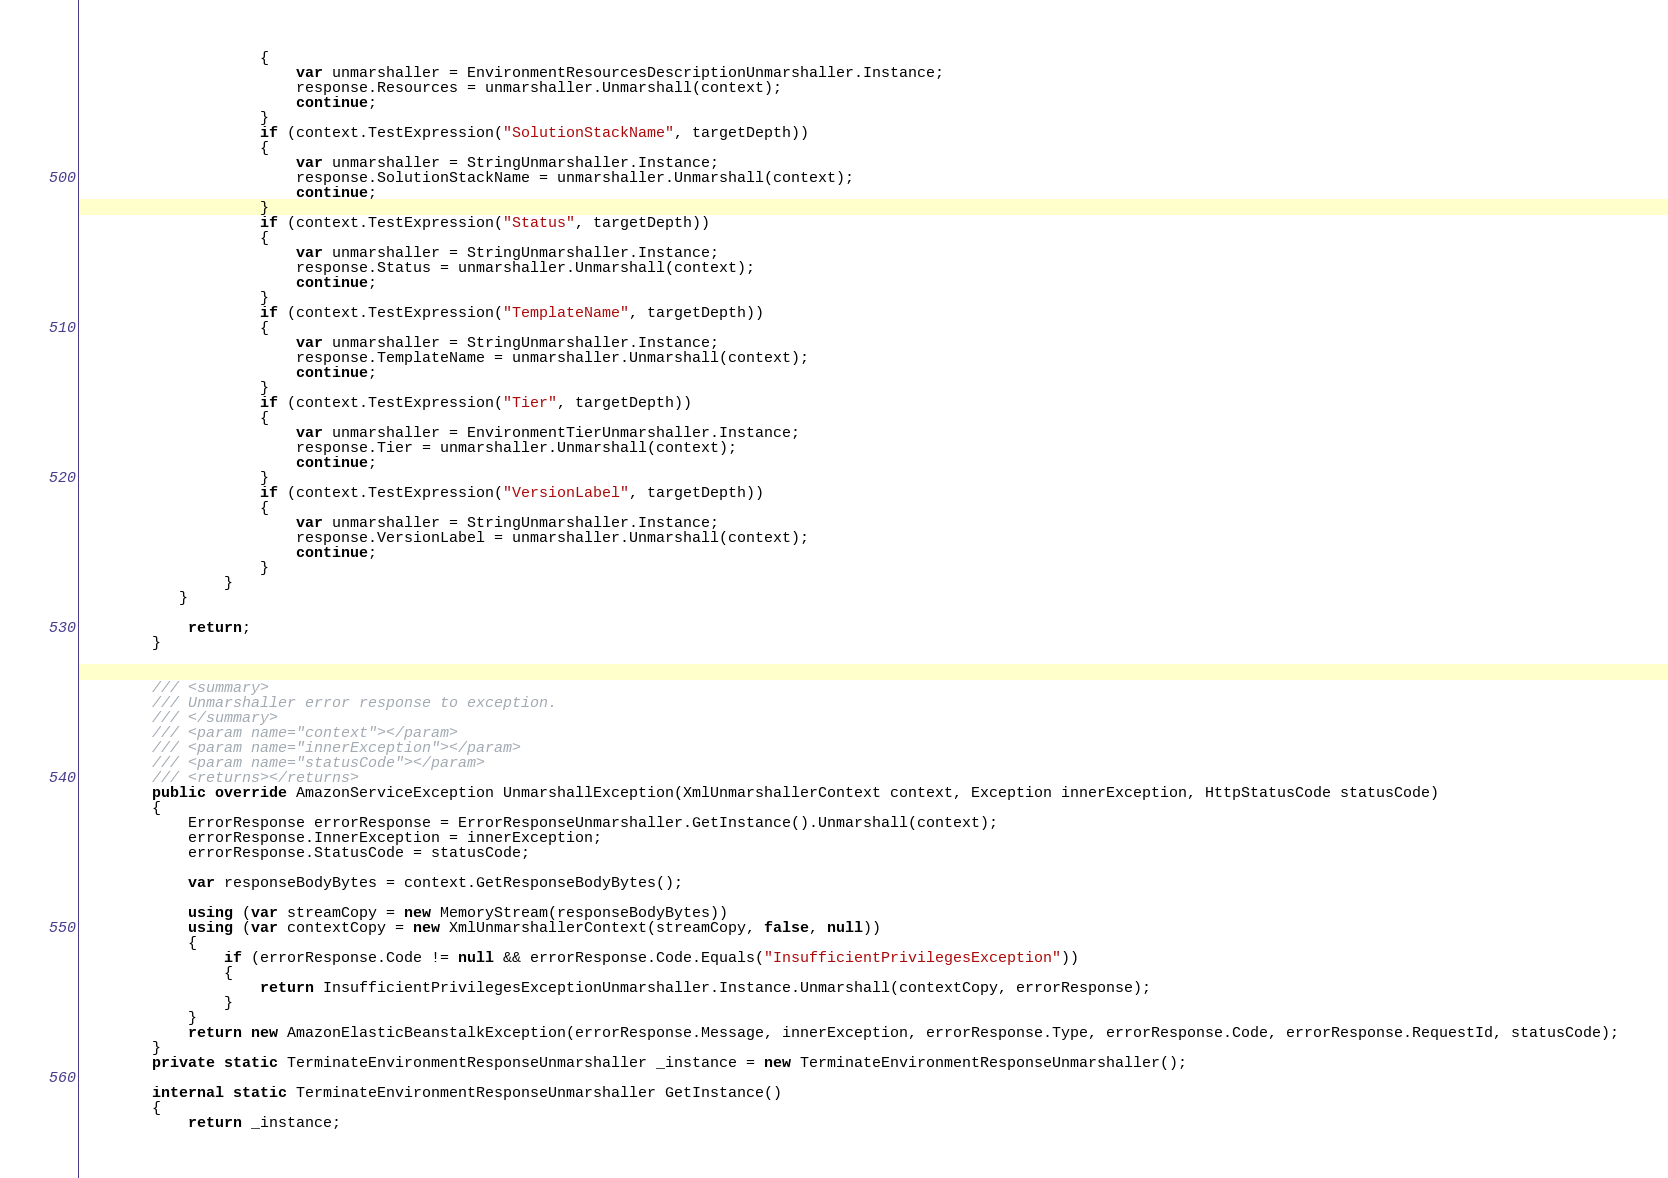Convert code to text. <code><loc_0><loc_0><loc_500><loc_500><_C#_>                    {
                        var unmarshaller = EnvironmentResourcesDescriptionUnmarshaller.Instance;
                        response.Resources = unmarshaller.Unmarshall(context);
                        continue;
                    }
                    if (context.TestExpression("SolutionStackName", targetDepth))
                    {
                        var unmarshaller = StringUnmarshaller.Instance;
                        response.SolutionStackName = unmarshaller.Unmarshall(context);
                        continue;
                    }
                    if (context.TestExpression("Status", targetDepth))
                    {
                        var unmarshaller = StringUnmarshaller.Instance;
                        response.Status = unmarshaller.Unmarshall(context);
                        continue;
                    }
                    if (context.TestExpression("TemplateName", targetDepth))
                    {
                        var unmarshaller = StringUnmarshaller.Instance;
                        response.TemplateName = unmarshaller.Unmarshall(context);
                        continue;
                    }
                    if (context.TestExpression("Tier", targetDepth))
                    {
                        var unmarshaller = EnvironmentTierUnmarshaller.Instance;
                        response.Tier = unmarshaller.Unmarshall(context);
                        continue;
                    }
                    if (context.TestExpression("VersionLabel", targetDepth))
                    {
                        var unmarshaller = StringUnmarshaller.Instance;
                        response.VersionLabel = unmarshaller.Unmarshall(context);
                        continue;
                    }
                } 
           }

            return;
        }


        /// <summary>
        /// Unmarshaller error response to exception.
        /// </summary>  
        /// <param name="context"></param>
        /// <param name="innerException"></param>
        /// <param name="statusCode"></param>
        /// <returns></returns>
        public override AmazonServiceException UnmarshallException(XmlUnmarshallerContext context, Exception innerException, HttpStatusCode statusCode)
        {
            ErrorResponse errorResponse = ErrorResponseUnmarshaller.GetInstance().Unmarshall(context);
            errorResponse.InnerException = innerException;
            errorResponse.StatusCode = statusCode;

            var responseBodyBytes = context.GetResponseBodyBytes();

            using (var streamCopy = new MemoryStream(responseBodyBytes))
            using (var contextCopy = new XmlUnmarshallerContext(streamCopy, false, null))
            {
                if (errorResponse.Code != null && errorResponse.Code.Equals("InsufficientPrivilegesException"))
                {
                    return InsufficientPrivilegesExceptionUnmarshaller.Instance.Unmarshall(contextCopy, errorResponse);
                }
            }
            return new AmazonElasticBeanstalkException(errorResponse.Message, innerException, errorResponse.Type, errorResponse.Code, errorResponse.RequestId, statusCode);
        }
        private static TerminateEnvironmentResponseUnmarshaller _instance = new TerminateEnvironmentResponseUnmarshaller();        

        internal static TerminateEnvironmentResponseUnmarshaller GetInstance()
        {
            return _instance;</code> 